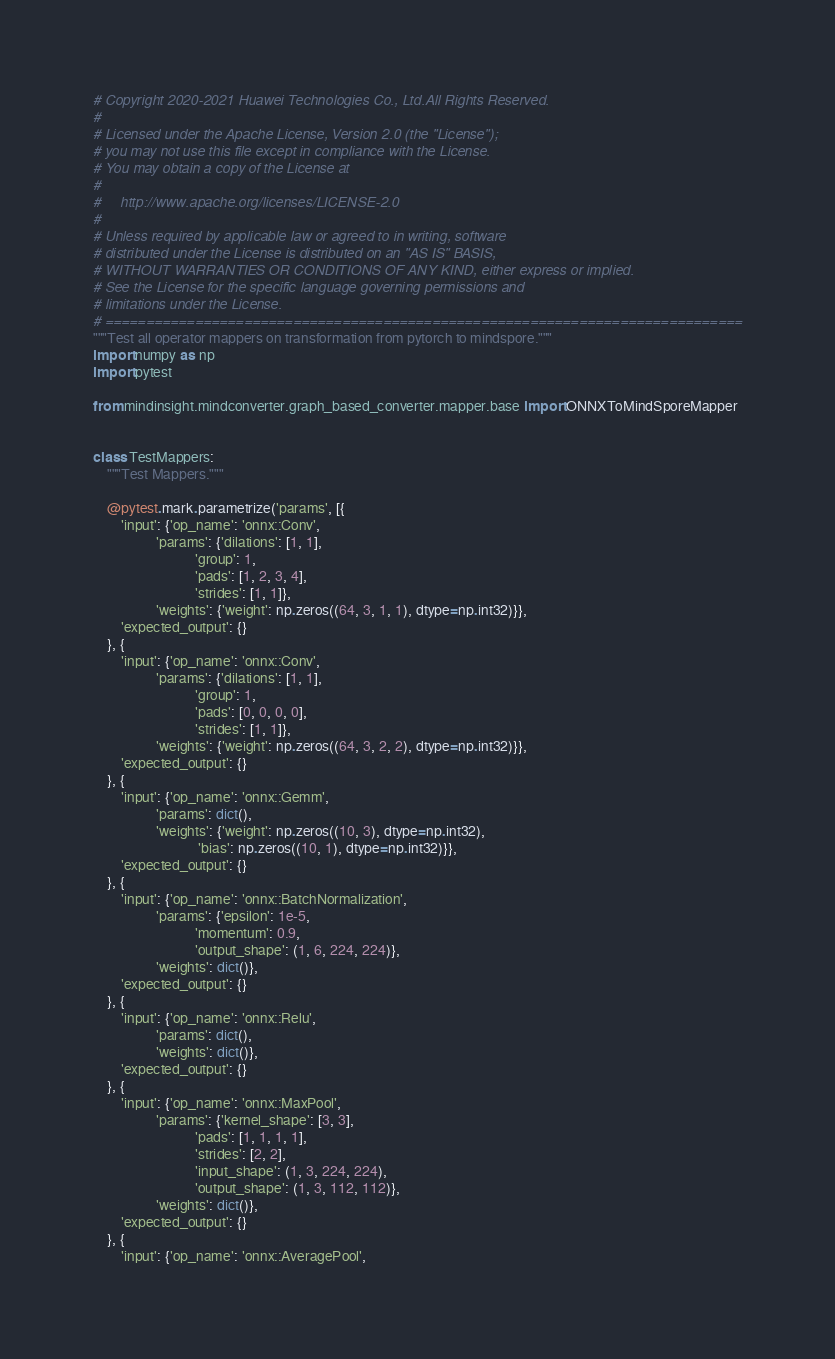Convert code to text. <code><loc_0><loc_0><loc_500><loc_500><_Python_># Copyright 2020-2021 Huawei Technologies Co., Ltd.All Rights Reserved.
#
# Licensed under the Apache License, Version 2.0 (the "License");
# you may not use this file except in compliance with the License.
# You may obtain a copy of the License at
#
#     http://www.apache.org/licenses/LICENSE-2.0
#
# Unless required by applicable law or agreed to in writing, software
# distributed under the License is distributed on an "AS IS" BASIS,
# WITHOUT WARRANTIES OR CONDITIONS OF ANY KIND, either express or implied.
# See the License for the specific language governing permissions and
# limitations under the License.
# ==============================================================================
"""Test all operator mappers on transformation from pytorch to mindspore."""
import numpy as np
import pytest

from mindinsight.mindconverter.graph_based_converter.mapper.base import ONNXToMindSporeMapper


class TestMappers:
    """Test Mappers."""

    @pytest.mark.parametrize('params', [{
        'input': {'op_name': 'onnx::Conv',
                  'params': {'dilations': [1, 1],
                             'group': 1,
                             'pads': [1, 2, 3, 4],
                             'strides': [1, 1]},
                  'weights': {'weight': np.zeros((64, 3, 1, 1), dtype=np.int32)}},
        'expected_output': {}
    }, {
        'input': {'op_name': 'onnx::Conv',
                  'params': {'dilations': [1, 1],
                             'group': 1,
                             'pads': [0, 0, 0, 0],
                             'strides': [1, 1]},
                  'weights': {'weight': np.zeros((64, 3, 2, 2), dtype=np.int32)}},
        'expected_output': {}
    }, {
        'input': {'op_name': 'onnx::Gemm',
                  'params': dict(),
                  'weights': {'weight': np.zeros((10, 3), dtype=np.int32),
                              'bias': np.zeros((10, 1), dtype=np.int32)}},
        'expected_output': {}
    }, {
        'input': {'op_name': 'onnx::BatchNormalization',
                  'params': {'epsilon': 1e-5,
                             'momentum': 0.9,
                             'output_shape': (1, 6, 224, 224)},
                  'weights': dict()},
        'expected_output': {}
    }, {
        'input': {'op_name': 'onnx::Relu',
                  'params': dict(),
                  'weights': dict()},
        'expected_output': {}
    }, {
        'input': {'op_name': 'onnx::MaxPool',
                  'params': {'kernel_shape': [3, 3],
                             'pads': [1, 1, 1, 1],
                             'strides': [2, 2],
                             'input_shape': (1, 3, 224, 224),
                             'output_shape': (1, 3, 112, 112)},
                  'weights': dict()},
        'expected_output': {}
    }, {
        'input': {'op_name': 'onnx::AveragePool',</code> 